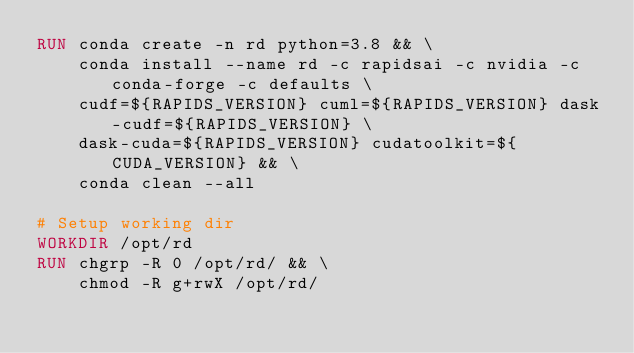<code> <loc_0><loc_0><loc_500><loc_500><_Dockerfile_>RUN conda create -n rd python=3.8 && \
    conda install --name rd -c rapidsai -c nvidia -c conda-forge -c defaults \
    cudf=${RAPIDS_VERSION} cuml=${RAPIDS_VERSION} dask-cudf=${RAPIDS_VERSION} \
    dask-cuda=${RAPIDS_VERSION} cudatoolkit=${CUDA_VERSION} && \
    conda clean --all

# Setup working dir
WORKDIR /opt/rd
RUN chgrp -R 0 /opt/rd/ && \
    chmod -R g+rwX /opt/rd/

</code> 